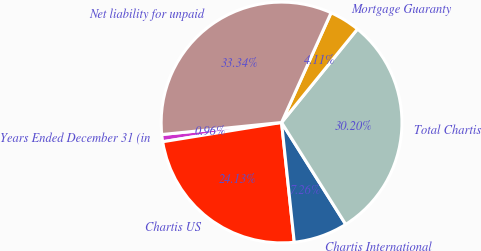Convert chart. <chart><loc_0><loc_0><loc_500><loc_500><pie_chart><fcel>Years Ended December 31 (in<fcel>Chartis US<fcel>Chartis International<fcel>Total Chartis<fcel>Mortgage Guaranty<fcel>Net liability for unpaid<nl><fcel>0.96%<fcel>24.13%<fcel>7.26%<fcel>30.2%<fcel>4.11%<fcel>33.34%<nl></chart> 